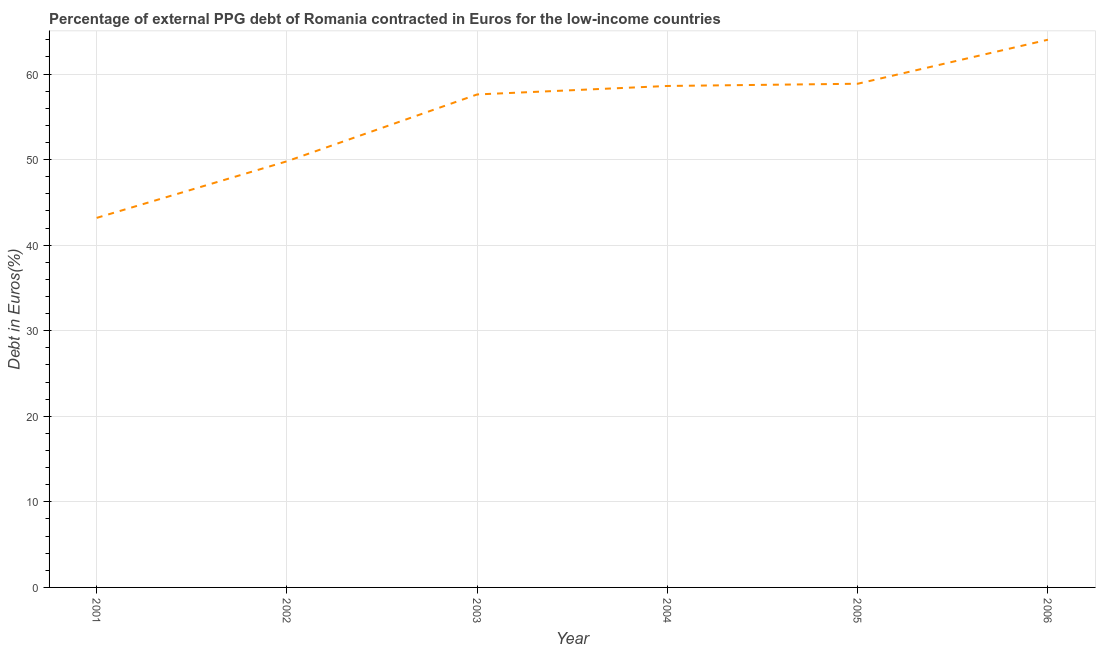What is the currency composition of ppg debt in 2006?
Your answer should be very brief. 64.01. Across all years, what is the maximum currency composition of ppg debt?
Provide a succinct answer. 64.01. Across all years, what is the minimum currency composition of ppg debt?
Your answer should be very brief. 43.19. In which year was the currency composition of ppg debt maximum?
Ensure brevity in your answer.  2006. In which year was the currency composition of ppg debt minimum?
Give a very brief answer. 2001. What is the sum of the currency composition of ppg debt?
Provide a short and direct response. 332.08. What is the difference between the currency composition of ppg debt in 2001 and 2003?
Give a very brief answer. -14.43. What is the average currency composition of ppg debt per year?
Keep it short and to the point. 55.35. What is the median currency composition of ppg debt?
Offer a very short reply. 58.11. Do a majority of the years between 2003 and 2005 (inclusive) have currency composition of ppg debt greater than 60 %?
Offer a very short reply. No. What is the ratio of the currency composition of ppg debt in 2003 to that in 2005?
Keep it short and to the point. 0.98. Is the currency composition of ppg debt in 2002 less than that in 2006?
Your response must be concise. Yes. Is the difference between the currency composition of ppg debt in 2001 and 2005 greater than the difference between any two years?
Ensure brevity in your answer.  No. What is the difference between the highest and the second highest currency composition of ppg debt?
Make the answer very short. 5.14. What is the difference between the highest and the lowest currency composition of ppg debt?
Provide a succinct answer. 20.82. In how many years, is the currency composition of ppg debt greater than the average currency composition of ppg debt taken over all years?
Give a very brief answer. 4. What is the difference between two consecutive major ticks on the Y-axis?
Provide a short and direct response. 10. What is the title of the graph?
Provide a short and direct response. Percentage of external PPG debt of Romania contracted in Euros for the low-income countries. What is the label or title of the Y-axis?
Give a very brief answer. Debt in Euros(%). What is the Debt in Euros(%) of 2001?
Your response must be concise. 43.19. What is the Debt in Euros(%) in 2002?
Offer a terse response. 49.8. What is the Debt in Euros(%) in 2003?
Your response must be concise. 57.61. What is the Debt in Euros(%) of 2004?
Offer a terse response. 58.6. What is the Debt in Euros(%) in 2005?
Offer a very short reply. 58.86. What is the Debt in Euros(%) in 2006?
Ensure brevity in your answer.  64.01. What is the difference between the Debt in Euros(%) in 2001 and 2002?
Give a very brief answer. -6.61. What is the difference between the Debt in Euros(%) in 2001 and 2003?
Make the answer very short. -14.43. What is the difference between the Debt in Euros(%) in 2001 and 2004?
Keep it short and to the point. -15.42. What is the difference between the Debt in Euros(%) in 2001 and 2005?
Offer a terse response. -15.68. What is the difference between the Debt in Euros(%) in 2001 and 2006?
Provide a short and direct response. -20.82. What is the difference between the Debt in Euros(%) in 2002 and 2003?
Make the answer very short. -7.81. What is the difference between the Debt in Euros(%) in 2002 and 2004?
Ensure brevity in your answer.  -8.8. What is the difference between the Debt in Euros(%) in 2002 and 2005?
Provide a short and direct response. -9.06. What is the difference between the Debt in Euros(%) in 2002 and 2006?
Your answer should be very brief. -14.2. What is the difference between the Debt in Euros(%) in 2003 and 2004?
Your answer should be very brief. -0.99. What is the difference between the Debt in Euros(%) in 2003 and 2005?
Give a very brief answer. -1.25. What is the difference between the Debt in Euros(%) in 2003 and 2006?
Offer a terse response. -6.39. What is the difference between the Debt in Euros(%) in 2004 and 2005?
Give a very brief answer. -0.26. What is the difference between the Debt in Euros(%) in 2004 and 2006?
Your answer should be compact. -5.4. What is the difference between the Debt in Euros(%) in 2005 and 2006?
Your response must be concise. -5.14. What is the ratio of the Debt in Euros(%) in 2001 to that in 2002?
Ensure brevity in your answer.  0.87. What is the ratio of the Debt in Euros(%) in 2001 to that in 2004?
Your answer should be compact. 0.74. What is the ratio of the Debt in Euros(%) in 2001 to that in 2005?
Provide a succinct answer. 0.73. What is the ratio of the Debt in Euros(%) in 2001 to that in 2006?
Ensure brevity in your answer.  0.68. What is the ratio of the Debt in Euros(%) in 2002 to that in 2003?
Give a very brief answer. 0.86. What is the ratio of the Debt in Euros(%) in 2002 to that in 2005?
Your answer should be compact. 0.85. What is the ratio of the Debt in Euros(%) in 2002 to that in 2006?
Offer a very short reply. 0.78. What is the ratio of the Debt in Euros(%) in 2003 to that in 2004?
Offer a terse response. 0.98. What is the ratio of the Debt in Euros(%) in 2003 to that in 2006?
Keep it short and to the point. 0.9. What is the ratio of the Debt in Euros(%) in 2004 to that in 2005?
Offer a terse response. 1. What is the ratio of the Debt in Euros(%) in 2004 to that in 2006?
Make the answer very short. 0.92. What is the ratio of the Debt in Euros(%) in 2005 to that in 2006?
Your answer should be very brief. 0.92. 